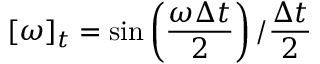Convert formula to latex. <formula><loc_0><loc_0><loc_500><loc_500>[ \omega ] _ { t } = \sin \left ( \frac { \omega \Delta t } { 2 } \right ) / \frac { \Delta t } { 2 }</formula> 